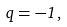Convert formula to latex. <formula><loc_0><loc_0><loc_500><loc_500>q = - 1 \, ,</formula> 